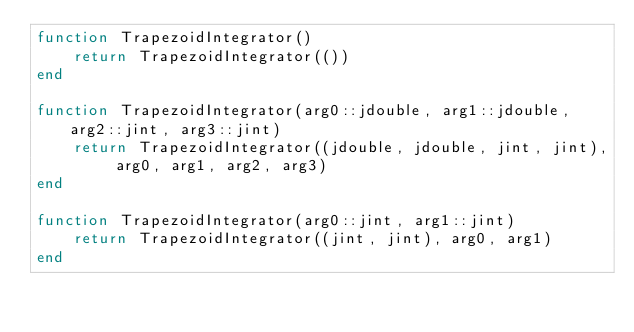<code> <loc_0><loc_0><loc_500><loc_500><_Julia_>function TrapezoidIntegrator()
    return TrapezoidIntegrator(())
end

function TrapezoidIntegrator(arg0::jdouble, arg1::jdouble, arg2::jint, arg3::jint)
    return TrapezoidIntegrator((jdouble, jdouble, jint, jint), arg0, arg1, arg2, arg3)
end

function TrapezoidIntegrator(arg0::jint, arg1::jint)
    return TrapezoidIntegrator((jint, jint), arg0, arg1)
end

</code> 